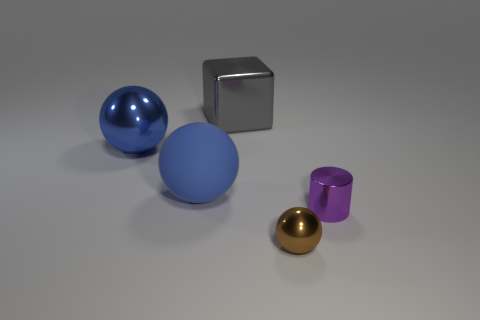What is the material of the small purple cylinder?
Provide a succinct answer. Metal. How many things are things on the right side of the brown ball or balls in front of the tiny purple metal object?
Offer a very short reply. 2. What number of other things are the same color as the tiny metal sphere?
Offer a very short reply. 0. Is the shape of the big gray object the same as the large object that is to the left of the big blue rubber thing?
Keep it short and to the point. No. Are there fewer gray cubes in front of the brown sphere than brown metal objects that are to the right of the big gray block?
Make the answer very short. Yes. What material is the other brown object that is the same shape as the matte object?
Offer a terse response. Metal. Is there anything else that is made of the same material as the small purple thing?
Provide a short and direct response. Yes. Is the tiny metal cylinder the same color as the rubber object?
Ensure brevity in your answer.  No. There is a brown object that is the same material as the tiny purple object; what shape is it?
Your answer should be very brief. Sphere. What number of other gray metal objects are the same shape as the gray object?
Provide a succinct answer. 0. 